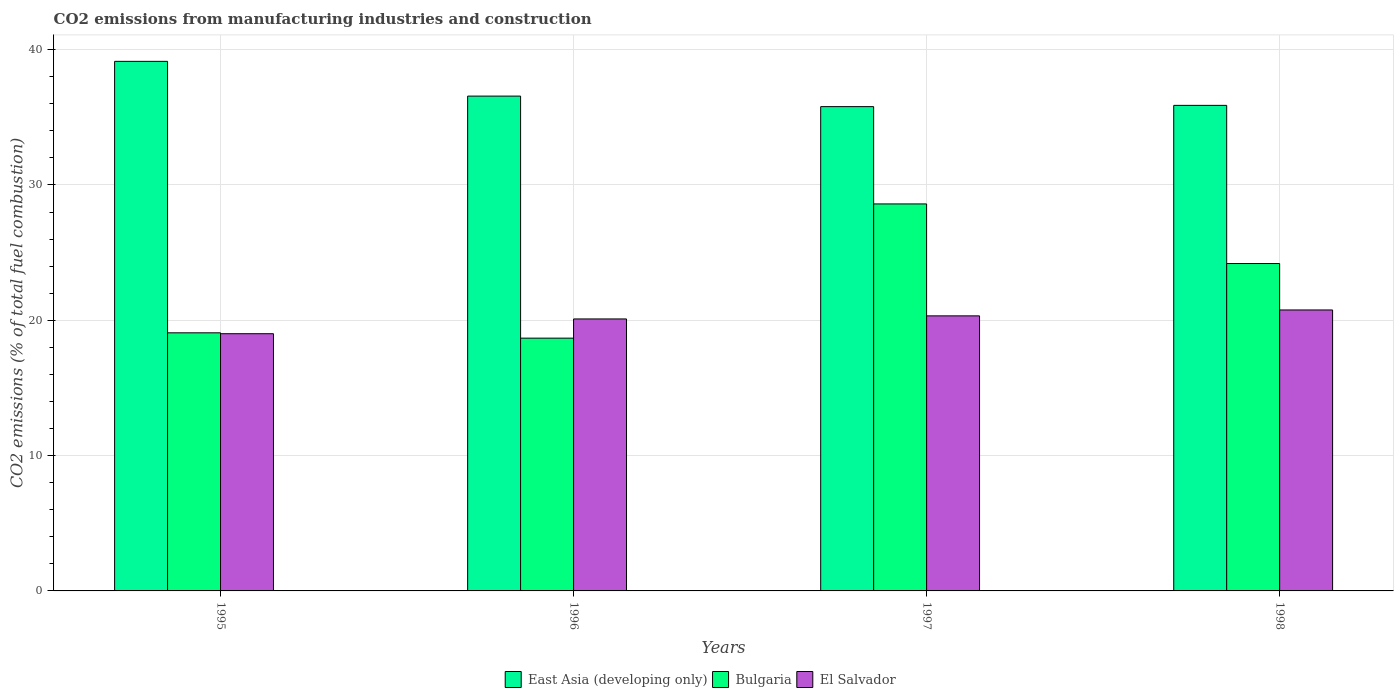How many groups of bars are there?
Give a very brief answer. 4. How many bars are there on the 2nd tick from the left?
Give a very brief answer. 3. How many bars are there on the 3rd tick from the right?
Your answer should be compact. 3. In how many cases, is the number of bars for a given year not equal to the number of legend labels?
Ensure brevity in your answer.  0. What is the amount of CO2 emitted in East Asia (developing only) in 1997?
Give a very brief answer. 35.79. Across all years, what is the maximum amount of CO2 emitted in East Asia (developing only)?
Your answer should be compact. 39.13. Across all years, what is the minimum amount of CO2 emitted in Bulgaria?
Provide a succinct answer. 18.68. What is the total amount of CO2 emitted in El Salvador in the graph?
Provide a short and direct response. 80.19. What is the difference between the amount of CO2 emitted in Bulgaria in 1997 and that in 1998?
Your answer should be very brief. 4.4. What is the difference between the amount of CO2 emitted in Bulgaria in 1997 and the amount of CO2 emitted in East Asia (developing only) in 1995?
Your answer should be compact. -10.54. What is the average amount of CO2 emitted in Bulgaria per year?
Offer a terse response. 22.64. In the year 1996, what is the difference between the amount of CO2 emitted in East Asia (developing only) and amount of CO2 emitted in Bulgaria?
Your answer should be very brief. 17.89. In how many years, is the amount of CO2 emitted in East Asia (developing only) greater than 2 %?
Provide a succinct answer. 4. What is the ratio of the amount of CO2 emitted in Bulgaria in 1995 to that in 1997?
Your answer should be very brief. 0.67. What is the difference between the highest and the second highest amount of CO2 emitted in Bulgaria?
Make the answer very short. 4.4. What is the difference between the highest and the lowest amount of CO2 emitted in East Asia (developing only)?
Your answer should be compact. 3.35. Is the sum of the amount of CO2 emitted in Bulgaria in 1995 and 1997 greater than the maximum amount of CO2 emitted in El Salvador across all years?
Provide a succinct answer. Yes. What does the 3rd bar from the left in 1997 represents?
Your answer should be very brief. El Salvador. What does the 1st bar from the right in 1998 represents?
Ensure brevity in your answer.  El Salvador. Is it the case that in every year, the sum of the amount of CO2 emitted in Bulgaria and amount of CO2 emitted in El Salvador is greater than the amount of CO2 emitted in East Asia (developing only)?
Ensure brevity in your answer.  No. Are all the bars in the graph horizontal?
Your response must be concise. No. Are the values on the major ticks of Y-axis written in scientific E-notation?
Ensure brevity in your answer.  No. How are the legend labels stacked?
Make the answer very short. Horizontal. What is the title of the graph?
Make the answer very short. CO2 emissions from manufacturing industries and construction. What is the label or title of the X-axis?
Make the answer very short. Years. What is the label or title of the Y-axis?
Keep it short and to the point. CO2 emissions (% of total fuel combustion). What is the CO2 emissions (% of total fuel combustion) of East Asia (developing only) in 1995?
Provide a succinct answer. 39.13. What is the CO2 emissions (% of total fuel combustion) in Bulgaria in 1995?
Offer a very short reply. 19.07. What is the CO2 emissions (% of total fuel combustion) of El Salvador in 1995?
Give a very brief answer. 19.01. What is the CO2 emissions (% of total fuel combustion) of East Asia (developing only) in 1996?
Provide a succinct answer. 36.56. What is the CO2 emissions (% of total fuel combustion) of Bulgaria in 1996?
Make the answer very short. 18.68. What is the CO2 emissions (% of total fuel combustion) of El Salvador in 1996?
Make the answer very short. 20.1. What is the CO2 emissions (% of total fuel combustion) in East Asia (developing only) in 1997?
Offer a very short reply. 35.79. What is the CO2 emissions (% of total fuel combustion) in Bulgaria in 1997?
Give a very brief answer. 28.6. What is the CO2 emissions (% of total fuel combustion) of El Salvador in 1997?
Your answer should be very brief. 20.33. What is the CO2 emissions (% of total fuel combustion) of East Asia (developing only) in 1998?
Keep it short and to the point. 35.88. What is the CO2 emissions (% of total fuel combustion) of Bulgaria in 1998?
Your answer should be very brief. 24.19. What is the CO2 emissions (% of total fuel combustion) of El Salvador in 1998?
Keep it short and to the point. 20.76. Across all years, what is the maximum CO2 emissions (% of total fuel combustion) of East Asia (developing only)?
Offer a very short reply. 39.13. Across all years, what is the maximum CO2 emissions (% of total fuel combustion) of Bulgaria?
Your response must be concise. 28.6. Across all years, what is the maximum CO2 emissions (% of total fuel combustion) in El Salvador?
Your answer should be compact. 20.76. Across all years, what is the minimum CO2 emissions (% of total fuel combustion) of East Asia (developing only)?
Your response must be concise. 35.79. Across all years, what is the minimum CO2 emissions (% of total fuel combustion) of Bulgaria?
Make the answer very short. 18.68. Across all years, what is the minimum CO2 emissions (% of total fuel combustion) in El Salvador?
Keep it short and to the point. 19.01. What is the total CO2 emissions (% of total fuel combustion) of East Asia (developing only) in the graph?
Make the answer very short. 147.36. What is the total CO2 emissions (% of total fuel combustion) of Bulgaria in the graph?
Ensure brevity in your answer.  90.54. What is the total CO2 emissions (% of total fuel combustion) in El Salvador in the graph?
Ensure brevity in your answer.  80.19. What is the difference between the CO2 emissions (% of total fuel combustion) in East Asia (developing only) in 1995 and that in 1996?
Provide a succinct answer. 2.57. What is the difference between the CO2 emissions (% of total fuel combustion) of Bulgaria in 1995 and that in 1996?
Offer a terse response. 0.39. What is the difference between the CO2 emissions (% of total fuel combustion) of El Salvador in 1995 and that in 1996?
Your answer should be very brief. -1.09. What is the difference between the CO2 emissions (% of total fuel combustion) of East Asia (developing only) in 1995 and that in 1997?
Your answer should be very brief. 3.35. What is the difference between the CO2 emissions (% of total fuel combustion) in Bulgaria in 1995 and that in 1997?
Offer a terse response. -9.52. What is the difference between the CO2 emissions (% of total fuel combustion) of El Salvador in 1995 and that in 1997?
Ensure brevity in your answer.  -1.32. What is the difference between the CO2 emissions (% of total fuel combustion) of East Asia (developing only) in 1995 and that in 1998?
Ensure brevity in your answer.  3.25. What is the difference between the CO2 emissions (% of total fuel combustion) in Bulgaria in 1995 and that in 1998?
Make the answer very short. -5.12. What is the difference between the CO2 emissions (% of total fuel combustion) of El Salvador in 1995 and that in 1998?
Ensure brevity in your answer.  -1.76. What is the difference between the CO2 emissions (% of total fuel combustion) of East Asia (developing only) in 1996 and that in 1997?
Your answer should be very brief. 0.78. What is the difference between the CO2 emissions (% of total fuel combustion) of Bulgaria in 1996 and that in 1997?
Give a very brief answer. -9.92. What is the difference between the CO2 emissions (% of total fuel combustion) of El Salvador in 1996 and that in 1997?
Provide a succinct answer. -0.23. What is the difference between the CO2 emissions (% of total fuel combustion) in East Asia (developing only) in 1996 and that in 1998?
Give a very brief answer. 0.68. What is the difference between the CO2 emissions (% of total fuel combustion) of Bulgaria in 1996 and that in 1998?
Provide a short and direct response. -5.51. What is the difference between the CO2 emissions (% of total fuel combustion) in El Salvador in 1996 and that in 1998?
Keep it short and to the point. -0.66. What is the difference between the CO2 emissions (% of total fuel combustion) of East Asia (developing only) in 1997 and that in 1998?
Keep it short and to the point. -0.09. What is the difference between the CO2 emissions (% of total fuel combustion) in Bulgaria in 1997 and that in 1998?
Your answer should be very brief. 4.41. What is the difference between the CO2 emissions (% of total fuel combustion) in El Salvador in 1997 and that in 1998?
Make the answer very short. -0.44. What is the difference between the CO2 emissions (% of total fuel combustion) of East Asia (developing only) in 1995 and the CO2 emissions (% of total fuel combustion) of Bulgaria in 1996?
Make the answer very short. 20.45. What is the difference between the CO2 emissions (% of total fuel combustion) of East Asia (developing only) in 1995 and the CO2 emissions (% of total fuel combustion) of El Salvador in 1996?
Provide a succinct answer. 19.03. What is the difference between the CO2 emissions (% of total fuel combustion) in Bulgaria in 1995 and the CO2 emissions (% of total fuel combustion) in El Salvador in 1996?
Your answer should be very brief. -1.03. What is the difference between the CO2 emissions (% of total fuel combustion) of East Asia (developing only) in 1995 and the CO2 emissions (% of total fuel combustion) of Bulgaria in 1997?
Provide a short and direct response. 10.54. What is the difference between the CO2 emissions (% of total fuel combustion) of East Asia (developing only) in 1995 and the CO2 emissions (% of total fuel combustion) of El Salvador in 1997?
Your answer should be very brief. 18.81. What is the difference between the CO2 emissions (% of total fuel combustion) in Bulgaria in 1995 and the CO2 emissions (% of total fuel combustion) in El Salvador in 1997?
Your answer should be very brief. -1.25. What is the difference between the CO2 emissions (% of total fuel combustion) in East Asia (developing only) in 1995 and the CO2 emissions (% of total fuel combustion) in Bulgaria in 1998?
Give a very brief answer. 14.94. What is the difference between the CO2 emissions (% of total fuel combustion) of East Asia (developing only) in 1995 and the CO2 emissions (% of total fuel combustion) of El Salvador in 1998?
Give a very brief answer. 18.37. What is the difference between the CO2 emissions (% of total fuel combustion) of Bulgaria in 1995 and the CO2 emissions (% of total fuel combustion) of El Salvador in 1998?
Offer a terse response. -1.69. What is the difference between the CO2 emissions (% of total fuel combustion) in East Asia (developing only) in 1996 and the CO2 emissions (% of total fuel combustion) in Bulgaria in 1997?
Provide a succinct answer. 7.97. What is the difference between the CO2 emissions (% of total fuel combustion) of East Asia (developing only) in 1996 and the CO2 emissions (% of total fuel combustion) of El Salvador in 1997?
Your answer should be compact. 16.24. What is the difference between the CO2 emissions (% of total fuel combustion) of Bulgaria in 1996 and the CO2 emissions (% of total fuel combustion) of El Salvador in 1997?
Provide a succinct answer. -1.65. What is the difference between the CO2 emissions (% of total fuel combustion) of East Asia (developing only) in 1996 and the CO2 emissions (% of total fuel combustion) of Bulgaria in 1998?
Your response must be concise. 12.37. What is the difference between the CO2 emissions (% of total fuel combustion) of East Asia (developing only) in 1996 and the CO2 emissions (% of total fuel combustion) of El Salvador in 1998?
Your answer should be compact. 15.8. What is the difference between the CO2 emissions (% of total fuel combustion) in Bulgaria in 1996 and the CO2 emissions (% of total fuel combustion) in El Salvador in 1998?
Ensure brevity in your answer.  -2.08. What is the difference between the CO2 emissions (% of total fuel combustion) of East Asia (developing only) in 1997 and the CO2 emissions (% of total fuel combustion) of Bulgaria in 1998?
Ensure brevity in your answer.  11.6. What is the difference between the CO2 emissions (% of total fuel combustion) in East Asia (developing only) in 1997 and the CO2 emissions (% of total fuel combustion) in El Salvador in 1998?
Offer a very short reply. 15.03. What is the difference between the CO2 emissions (% of total fuel combustion) of Bulgaria in 1997 and the CO2 emissions (% of total fuel combustion) of El Salvador in 1998?
Your answer should be very brief. 7.83. What is the average CO2 emissions (% of total fuel combustion) of East Asia (developing only) per year?
Make the answer very short. 36.84. What is the average CO2 emissions (% of total fuel combustion) of Bulgaria per year?
Your response must be concise. 22.64. What is the average CO2 emissions (% of total fuel combustion) of El Salvador per year?
Make the answer very short. 20.05. In the year 1995, what is the difference between the CO2 emissions (% of total fuel combustion) of East Asia (developing only) and CO2 emissions (% of total fuel combustion) of Bulgaria?
Make the answer very short. 20.06. In the year 1995, what is the difference between the CO2 emissions (% of total fuel combustion) in East Asia (developing only) and CO2 emissions (% of total fuel combustion) in El Salvador?
Ensure brevity in your answer.  20.13. In the year 1995, what is the difference between the CO2 emissions (% of total fuel combustion) of Bulgaria and CO2 emissions (% of total fuel combustion) of El Salvador?
Offer a terse response. 0.07. In the year 1996, what is the difference between the CO2 emissions (% of total fuel combustion) in East Asia (developing only) and CO2 emissions (% of total fuel combustion) in Bulgaria?
Provide a succinct answer. 17.89. In the year 1996, what is the difference between the CO2 emissions (% of total fuel combustion) of East Asia (developing only) and CO2 emissions (% of total fuel combustion) of El Salvador?
Ensure brevity in your answer.  16.47. In the year 1996, what is the difference between the CO2 emissions (% of total fuel combustion) in Bulgaria and CO2 emissions (% of total fuel combustion) in El Salvador?
Provide a succinct answer. -1.42. In the year 1997, what is the difference between the CO2 emissions (% of total fuel combustion) in East Asia (developing only) and CO2 emissions (% of total fuel combustion) in Bulgaria?
Offer a terse response. 7.19. In the year 1997, what is the difference between the CO2 emissions (% of total fuel combustion) of East Asia (developing only) and CO2 emissions (% of total fuel combustion) of El Salvador?
Your answer should be compact. 15.46. In the year 1997, what is the difference between the CO2 emissions (% of total fuel combustion) of Bulgaria and CO2 emissions (% of total fuel combustion) of El Salvador?
Provide a short and direct response. 8.27. In the year 1998, what is the difference between the CO2 emissions (% of total fuel combustion) in East Asia (developing only) and CO2 emissions (% of total fuel combustion) in Bulgaria?
Give a very brief answer. 11.69. In the year 1998, what is the difference between the CO2 emissions (% of total fuel combustion) of East Asia (developing only) and CO2 emissions (% of total fuel combustion) of El Salvador?
Provide a succinct answer. 15.12. In the year 1998, what is the difference between the CO2 emissions (% of total fuel combustion) of Bulgaria and CO2 emissions (% of total fuel combustion) of El Salvador?
Ensure brevity in your answer.  3.43. What is the ratio of the CO2 emissions (% of total fuel combustion) of East Asia (developing only) in 1995 to that in 1996?
Offer a very short reply. 1.07. What is the ratio of the CO2 emissions (% of total fuel combustion) of Bulgaria in 1995 to that in 1996?
Your response must be concise. 1.02. What is the ratio of the CO2 emissions (% of total fuel combustion) of El Salvador in 1995 to that in 1996?
Your answer should be very brief. 0.95. What is the ratio of the CO2 emissions (% of total fuel combustion) of East Asia (developing only) in 1995 to that in 1997?
Your answer should be very brief. 1.09. What is the ratio of the CO2 emissions (% of total fuel combustion) of Bulgaria in 1995 to that in 1997?
Provide a short and direct response. 0.67. What is the ratio of the CO2 emissions (% of total fuel combustion) in El Salvador in 1995 to that in 1997?
Provide a short and direct response. 0.94. What is the ratio of the CO2 emissions (% of total fuel combustion) in East Asia (developing only) in 1995 to that in 1998?
Give a very brief answer. 1.09. What is the ratio of the CO2 emissions (% of total fuel combustion) in Bulgaria in 1995 to that in 1998?
Give a very brief answer. 0.79. What is the ratio of the CO2 emissions (% of total fuel combustion) in El Salvador in 1995 to that in 1998?
Your response must be concise. 0.92. What is the ratio of the CO2 emissions (% of total fuel combustion) in East Asia (developing only) in 1996 to that in 1997?
Your answer should be compact. 1.02. What is the ratio of the CO2 emissions (% of total fuel combustion) in Bulgaria in 1996 to that in 1997?
Your response must be concise. 0.65. What is the ratio of the CO2 emissions (% of total fuel combustion) of El Salvador in 1996 to that in 1997?
Your answer should be very brief. 0.99. What is the ratio of the CO2 emissions (% of total fuel combustion) in East Asia (developing only) in 1996 to that in 1998?
Your answer should be very brief. 1.02. What is the ratio of the CO2 emissions (% of total fuel combustion) of Bulgaria in 1996 to that in 1998?
Give a very brief answer. 0.77. What is the ratio of the CO2 emissions (% of total fuel combustion) in East Asia (developing only) in 1997 to that in 1998?
Offer a terse response. 1. What is the ratio of the CO2 emissions (% of total fuel combustion) in Bulgaria in 1997 to that in 1998?
Your response must be concise. 1.18. What is the ratio of the CO2 emissions (% of total fuel combustion) of El Salvador in 1997 to that in 1998?
Your response must be concise. 0.98. What is the difference between the highest and the second highest CO2 emissions (% of total fuel combustion) of East Asia (developing only)?
Give a very brief answer. 2.57. What is the difference between the highest and the second highest CO2 emissions (% of total fuel combustion) of Bulgaria?
Make the answer very short. 4.41. What is the difference between the highest and the second highest CO2 emissions (% of total fuel combustion) in El Salvador?
Offer a very short reply. 0.44. What is the difference between the highest and the lowest CO2 emissions (% of total fuel combustion) in East Asia (developing only)?
Offer a terse response. 3.35. What is the difference between the highest and the lowest CO2 emissions (% of total fuel combustion) of Bulgaria?
Your response must be concise. 9.92. What is the difference between the highest and the lowest CO2 emissions (% of total fuel combustion) in El Salvador?
Offer a terse response. 1.76. 